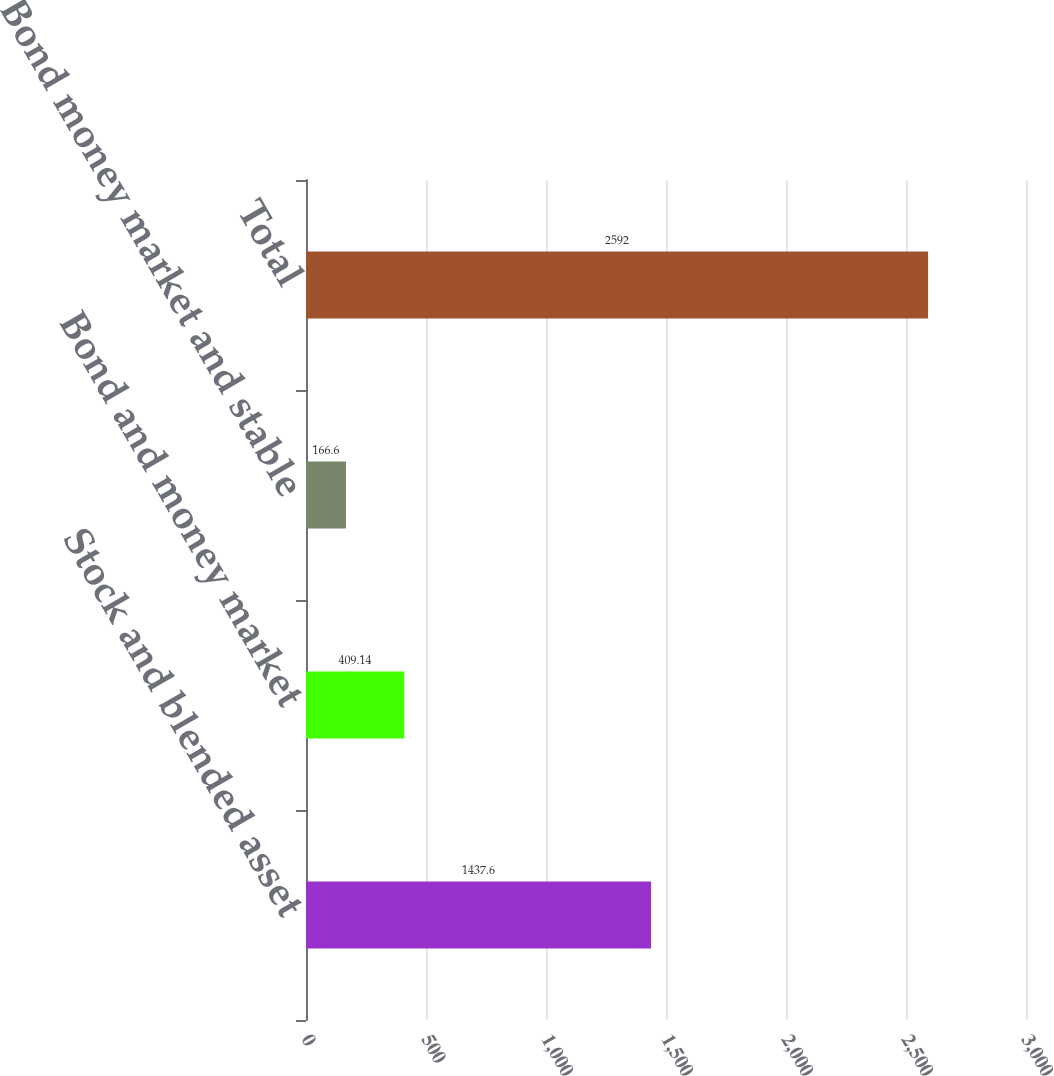Convert chart to OTSL. <chart><loc_0><loc_0><loc_500><loc_500><bar_chart><fcel>Stock and blended asset<fcel>Bond and money market<fcel>Bond money market and stable<fcel>Total<nl><fcel>1437.6<fcel>409.14<fcel>166.6<fcel>2592<nl></chart> 